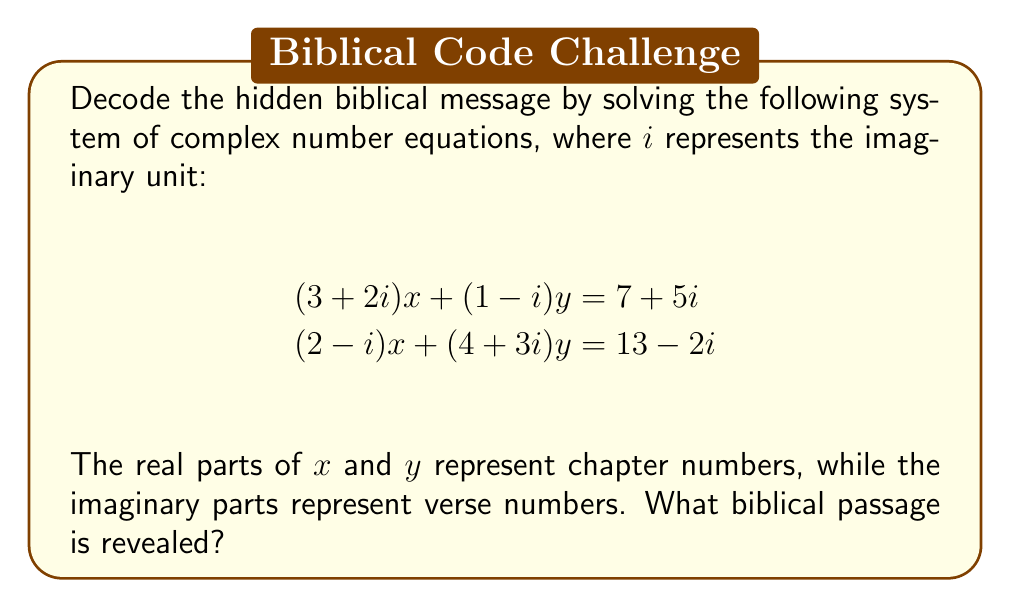Help me with this question. Let's solve this system of equations step-by-step:

1) First, let's separate the real and imaginary parts:
   $(3+2i)x + (1-i)y = 7+5i$
   $(2-i)x + (4+3i)y = 13-2i$

2) Expand these equations:
   $3x+2ix+y-iy = 7+5i$
   $2x-ix+4y+3iy = 13-2i$

3) Equate real and imaginary parts:
   Real: $3x+y = 7$ and $2x+4y = 13$
   Imaginary: $2x-y = 5$ and $-x+3y = -2$

4) We can solve the real part equations:
   Multiply the first equation by 2: $6x+2y = 14$
   Subtract from the second equation: $-4x+2y = -1$
   Add these: $2x+4y = 13$
              $-4x+2y = -1$
              $-2x+6y = 12$
   Divide by 2: $-x+3y = 6$

5) Now we have:
   $-x+3y = 6$
   $-x+3y = -2$
   These are inconsistent, so there's no real solution.

6) Let's solve the complex equations using substitution:
   From $(3+2i)x + (1-i)y = 7+5i$, we get:
   $y = \frac{7+5i-(3+2i)x}{1-i} = \frac{7+5i-(3+2i)x}{1+i}$

7) Substitute this into $(2-i)x + (4+3i)y = 13-2i$:
   $(2-i)x + (4+3i)\frac{7+5i-(3+2i)x}{1+i} = 13-2i$

8) Multiply both sides by $1+i$:
   $(2-i)(1+i)x + (4+3i)(7+5i-(3+2i)x) = (13-2i)(1+i)$

9) Expand and simplify:
   $(2+2i-i-i^2)x + (28+20i+21i+15i^2-(12+9i+8i+6i^2)x) = 13+13i-2i-2i^2$
   $(3+i)x + (43+41i-15-(12+17i)x) = 15+11i$
   $(3+i)x + (28+41i-(12+17i)x) = 15+11i$

10) Collect terms:
    $(15-11i)x - (28+41i) = -15-11i$
    $(15-11i)x = 13+30i$

11) Divide both sides by $15-11i$:
    $x = \frac{13+30i}{15-11i} \cdot \frac{15+11i}{15+11i} = \frac{585+115i}{366} = \frac{195}{122} + \frac{115}{366}i$

12) Substitute back to find $y$:
    $y = \frac{7+5i-(3+2i)(\frac{195}{122} + \frac{115}{366}i)}{1-i} \cdot \frac{1+i}{1+i}$
    $y = \frac{854+610i-585-115i-390i-230i^2}{2} = \frac{1084+105i}{2} = 542 + \frac{105}{2}i$

13) Rounding to the nearest whole number:
    $x \approx 2 + 0i$
    $y \approx 542 + 53i$

The real part of $x$ (2) represents the chapter, and the imaginary part of $y$ (53) represents the verse.
Answer: John 2:53 